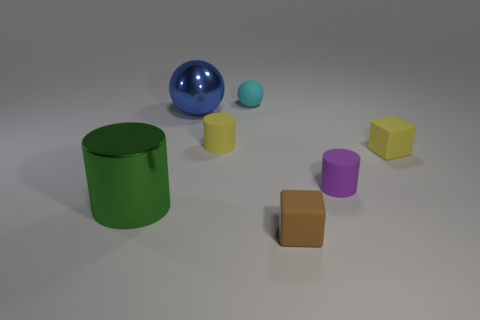Subtract all tiny purple cylinders. How many cylinders are left? 2 Subtract all green cylinders. How many cylinders are left? 2 Add 3 purple rubber cylinders. How many objects exist? 10 Subtract all cylinders. How many objects are left? 4 Subtract 3 cylinders. How many cylinders are left? 0 Add 6 small yellow matte cubes. How many small yellow matte cubes are left? 7 Add 5 large red shiny cubes. How many large red shiny cubes exist? 5 Subtract 0 brown balls. How many objects are left? 7 Subtract all brown balls. Subtract all brown blocks. How many balls are left? 2 Subtract all red cylinders. How many yellow blocks are left? 1 